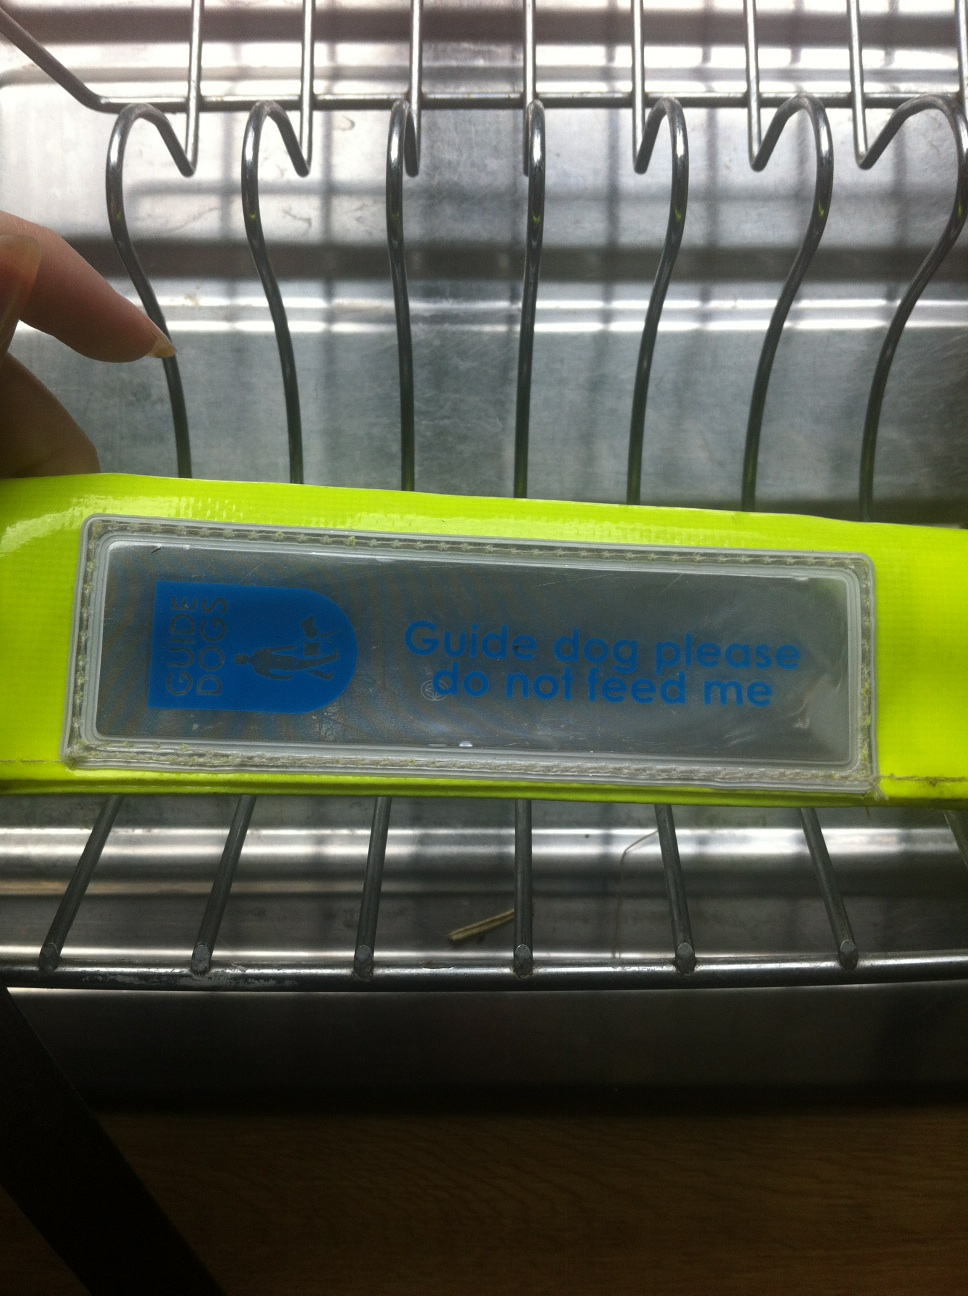What does my [sign from Vizwiz] say? The sign in the image reads, 'Guide dog please do not feed me.' It appears to be attached to a brightly colored leash or harness, which suggests it's associated with a guide dog. This message is designed to inform people that the dog is a working service animal and should not be fed, as doing so can disrupt its training and behaviour. 